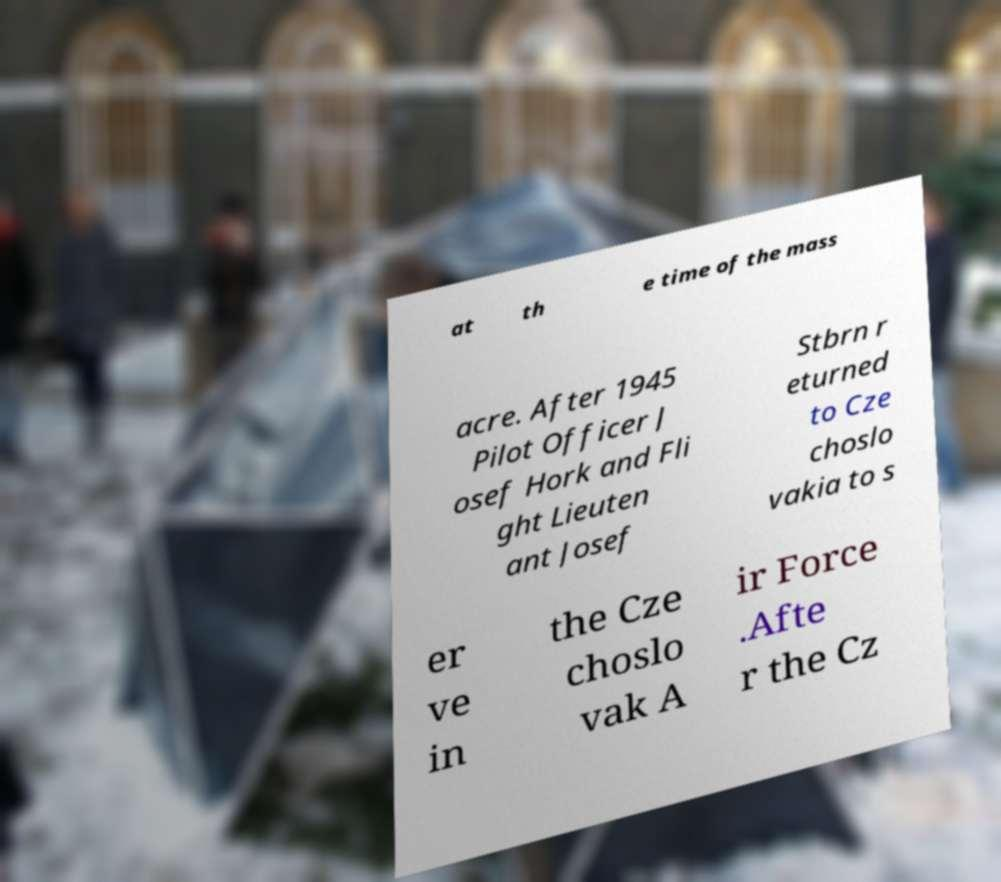Can you accurately transcribe the text from the provided image for me? at th e time of the mass acre. After 1945 Pilot Officer J osef Hork and Fli ght Lieuten ant Josef Stbrn r eturned to Cze choslo vakia to s er ve in the Cze choslo vak A ir Force .Afte r the Cz 